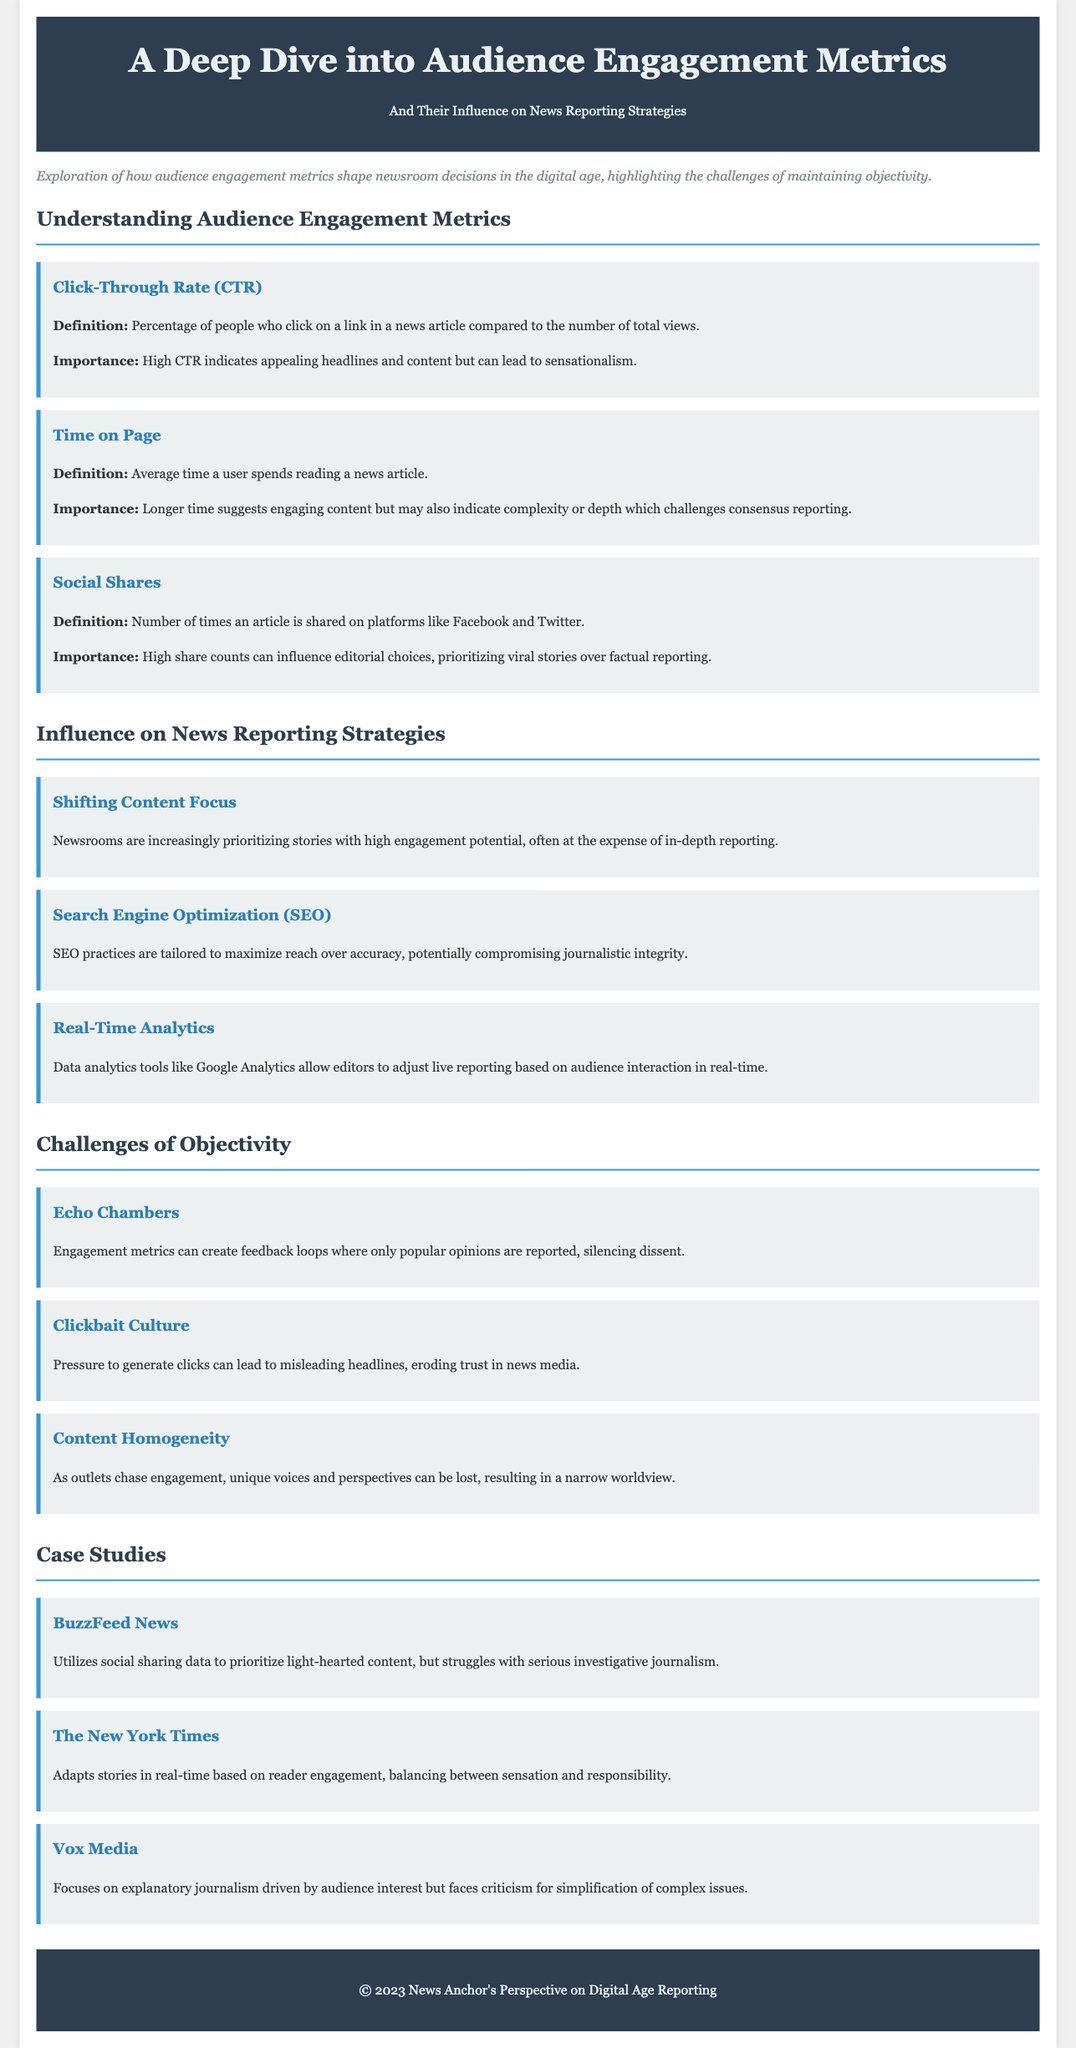What is the definition of Click-Through Rate (CTR)? The document provides the definition of CTR as the percentage of people who click on a link in a news article compared to the number of total views.
Answer: Percentage of people who click on a link in a news article compared to the number of total views What does a high Time on Page suggest? According to the document, a longer time spent on a page suggests engaging content but may also indicate complexity or depth.
Answer: Engaging content or complexity What do social shares indicate? The document states that high share counts can influence editorial choices, prioritizing viral stories over factual reporting.
Answer: Influence editorial choices What is one challenge of objectivity mentioned in the document? The document lists several challenges of objectivity, one of which is "Clickbait Culture," which can lead to misleading headlines.
Answer: Clickbait Culture How does BuzzFeed News utilize audience metrics? The document mentions that BuzzFeed News utilizes social sharing data to prioritize light-hearted content.
Answer: Prioritize light-hearted content What does SEO stand for? SEO is mentioned in the document as a practice tailored to maximize reach over accuracy, but its full form is not explicitly stated.
Answer: Search Engine Optimization What effect do echo chambers have on news reporting? The document explains that engagement metrics can create feedback loops where only popular opinions are reported.
Answer: Create feedback loops Which case study discusses balancing sensation and responsibility? The document lists The New York Times as adapting stories in real-time based on reader engagement while balancing sensation and responsibility.
Answer: The New York Times What type of content does Vox Media focus on? The document indicates that Vox Media focuses on explanatory journalism driven by audience interest.
Answer: Explanatory journalism 